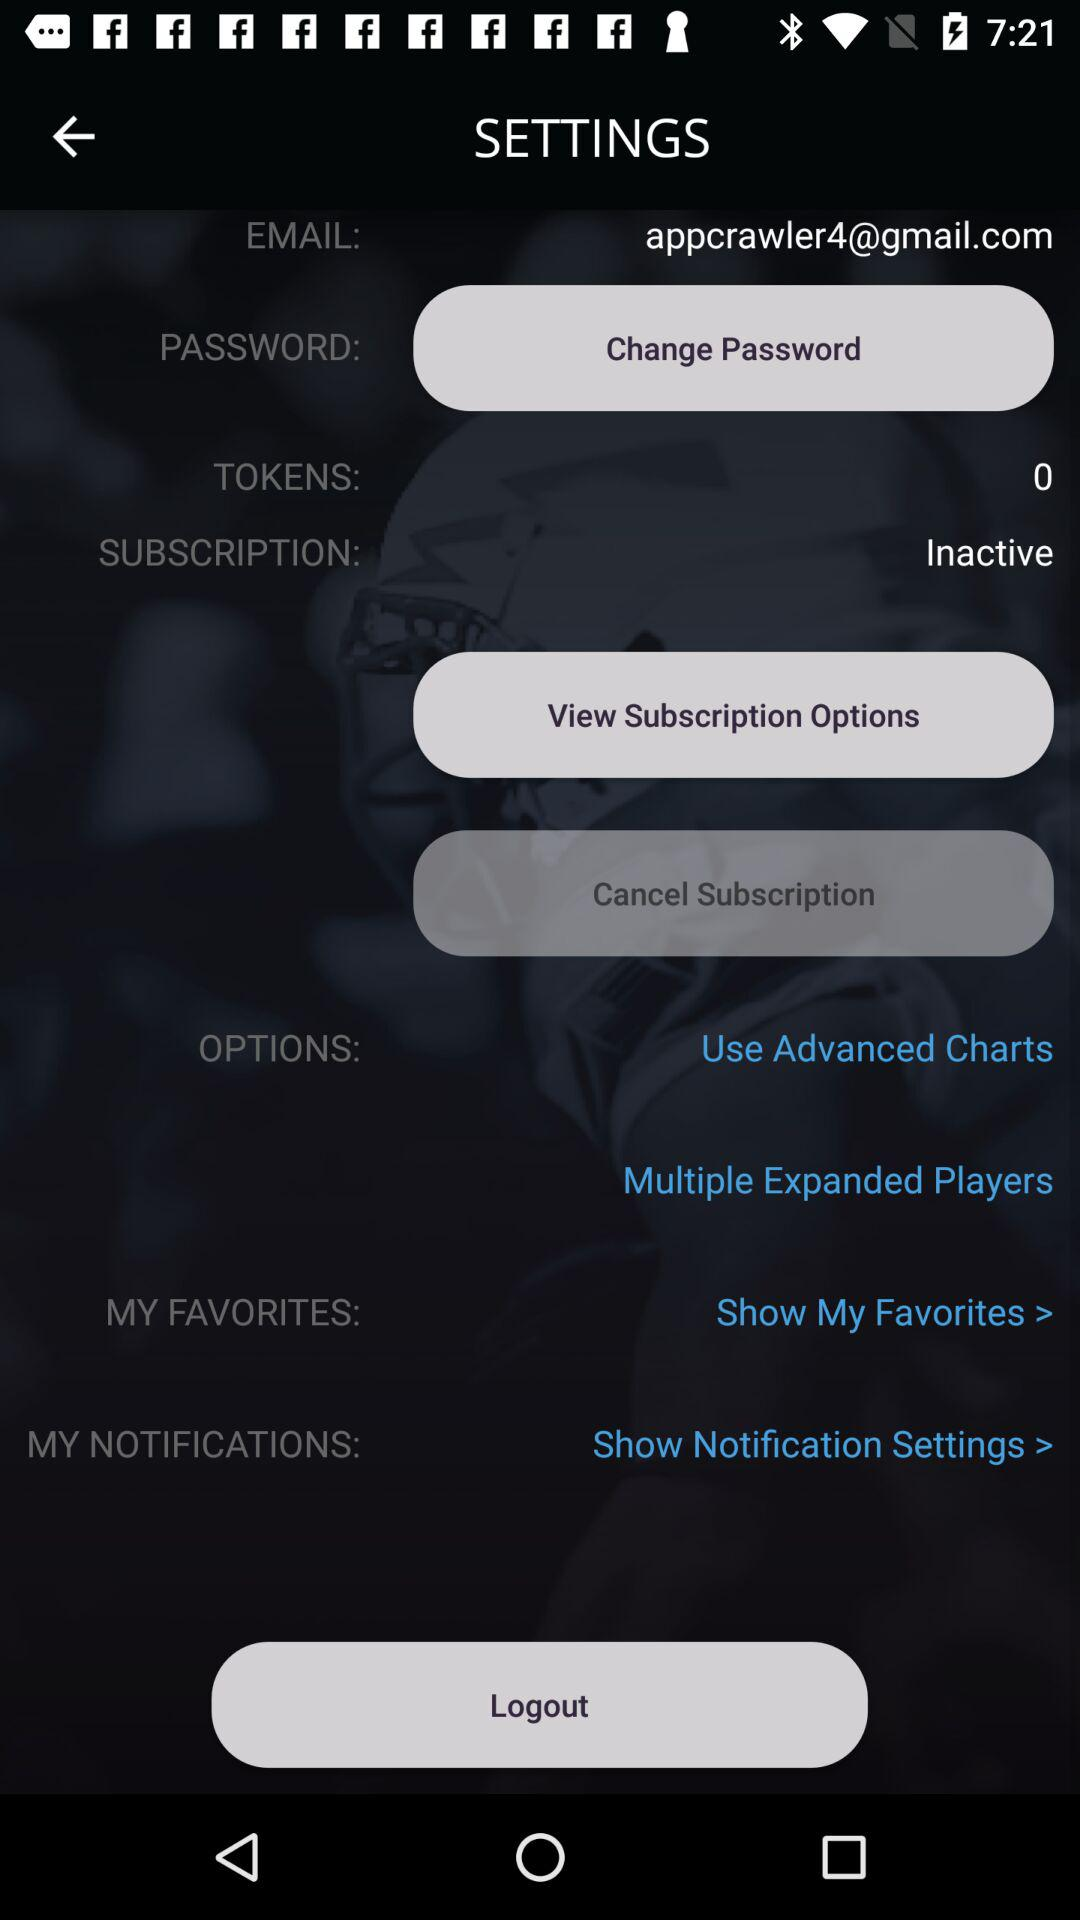What is the email address? The email address is appcrawler4@gmail.com. 